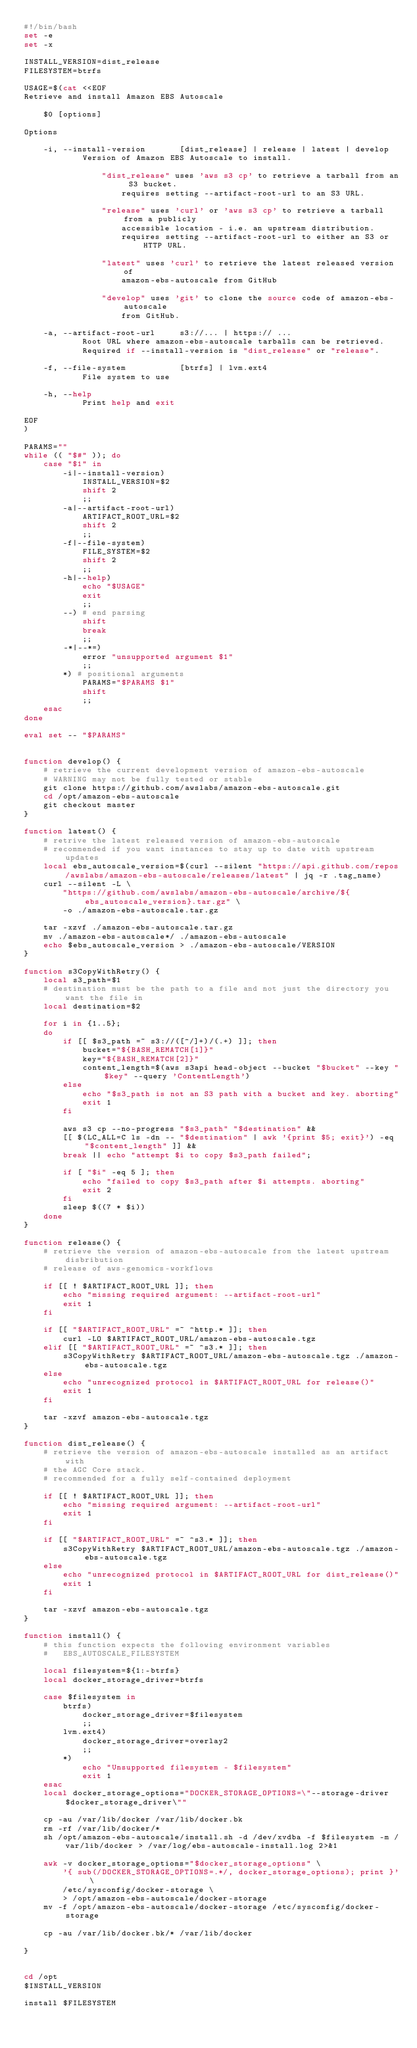<code> <loc_0><loc_0><loc_500><loc_500><_Bash_>#!/bin/bash
set -e
set -x

INSTALL_VERSION=dist_release
FILESYSTEM=btrfs

USAGE=$(cat <<EOF
Retrieve and install Amazon EBS Autoscale

    $0 [options]

Options

    -i, --install-version       [dist_release] | release | latest | develop
            Version of Amazon EBS Autoscale to install.
            
                "dist_release" uses 'aws s3 cp' to retrieve a tarball from an S3 bucket.
                    requires setting --artifact-root-url to an S3 URL.

                "release" uses 'curl' or 'aws s3 cp' to retrieve a tarball from a publicly 
                    accessible location - i.e. an upstream distribution.
                    requires setting --artifact-root-url to either an S3 or HTTP URL.
                
                "latest" uses 'curl' to retrieve the latest released version of 
                    amazon-ebs-autoscale from GitHub
                
                "develop" uses 'git' to clone the source code of amazon-ebs-autoscale
                    from GitHub.
    
    -a, --artifact-root-url     s3://... | https:// ...
            Root URL where amazon-ebs-autoscale tarballs can be retrieved.
            Required if --install-version is "dist_release" or "release".
    
    -f, --file-system           [btrfs] | lvm.ext4
            File system to use
    
    -h, --help
            Print help and exit

EOF
)

PARAMS=""
while (( "$#" )); do
    case "$1" in
        -i|--install-version)
            INSTALL_VERSION=$2
            shift 2
            ;;
        -a|--artifact-root-url)
            ARTIFACT_ROOT_URL=$2
            shift 2
            ;;
        -f|--file-system)
            FILE_SYSTEM=$2
            shift 2
            ;;
        -h|--help)
            echo "$USAGE"
            exit
            ;;
        --) # end parsing
            shift
            break
            ;;
        -*|--*=)
            error "unsupported argument $1"
            ;;
        *) # positional arguments
            PARAMS="$PARAMS $1"
            shift
            ;;
    esac
done

eval set -- "$PARAMS"


function develop() {
    # retrieve the current development version of amazon-ebs-autoscale
    # WARNING may not be fully tested or stable
    git clone https://github.com/awslabs/amazon-ebs-autoscale.git
    cd /opt/amazon-ebs-autoscale
    git checkout master
}

function latest() {
    # retrive the latest released version of amazon-ebs-autoscale
    # recommended if you want instances to stay up to date with upstream updates
    local ebs_autoscale_version=$(curl --silent "https://api.github.com/repos/awslabs/amazon-ebs-autoscale/releases/latest" | jq -r .tag_name)
    curl --silent -L \
        "https://github.com/awslabs/amazon-ebs-autoscale/archive/${ebs_autoscale_version}.tar.gz" \
        -o ./amazon-ebs-autoscale.tar.gz 

    tar -xzvf ./amazon-ebs-autoscale.tar.gz
    mv ./amazon-ebs-autoscale*/ ./amazon-ebs-autoscale
    echo $ebs_autoscale_version > ./amazon-ebs-autoscale/VERSION
}

function s3CopyWithRetry() {
    local s3_path=$1
    # destination must be the path to a file and not just the directory you want the file in
    local destination=$2

    for i in {1..5};
    do
        if [[ $s3_path =~ s3://([^/]+)/(.+) ]]; then
            bucket="${BASH_REMATCH[1]}"
            key="${BASH_REMATCH[2]}"
            content_length=$(aws s3api head-object --bucket "$bucket" --key "$key" --query 'ContentLength')
        else
            echo "$s3_path is not an S3 path with a bucket and key. aborting"
            exit 1
        fi
        
        aws s3 cp --no-progress "$s3_path" "$destination" &&
        [[ $(LC_ALL=C ls -dn -- "$destination" | awk '{print $5; exit}') -eq "$content_length" ]] &&
        break || echo "attempt $i to copy $s3_path failed";

        if [ "$i" -eq 5 ]; then
            echo "failed to copy $s3_path after $i attempts. aborting"
            exit 2
        fi
        sleep $((7 * $i))
    done
}

function release() {
    # retrieve the version of amazon-ebs-autoscale from the latest upstream disbribution 
    # release of aws-genomics-workflows

    if [[ ! $ARTIFACT_ROOT_URL ]]; then
        echo "missing required argument: --artifact-root-url"
        exit 1
    fi

    if [[ "$ARTIFACT_ROOT_URL" =~ ^http.* ]]; then
        curl -LO $ARTIFACT_ROOT_URL/amazon-ebs-autoscale.tgz
    elif [[ "$ARTIFACT_ROOT_URL" =~ ^s3.* ]]; then
        s3CopyWithRetry $ARTIFACT_ROOT_URL/amazon-ebs-autoscale.tgz ./amazon-ebs-autoscale.tgz
    else
        echo "unrecognized protocol in $ARTIFACT_ROOT_URL for release()"
        exit 1
    fi

    tar -xzvf amazon-ebs-autoscale.tgz
}

function dist_release() {
    # retrieve the version of amazon-ebs-autoscale installed as an artifact with
    # the AGC Core stack.
    # recommended for a fully self-contained deployment

    if [[ ! $ARTIFACT_ROOT_URL ]]; then
        echo "missing required argument: --artifact-root-url"
        exit 1
    fi

    if [[ "$ARTIFACT_ROOT_URL" =~ ^s3.* ]]; then
        s3CopyWithRetry $ARTIFACT_ROOT_URL/amazon-ebs-autoscale.tgz ./amazon-ebs-autoscale.tgz
    else
        echo "unrecognized protocol in $ARTIFACT_ROOT_URL for dist_release()"
        exit 1
    fi

    tar -xzvf amazon-ebs-autoscale.tgz
}

function install() {
    # this function expects the following environment variables
    #   EBS_AUTOSCALE_FILESYSTEM

    local filesystem=${1:-btrfs}
    local docker_storage_driver=btrfs

    case $filesystem in
        btrfs)
            docker_storage_driver=$filesystem
            ;;
        lvm.ext4)
            docker_storage_driver=overlay2
            ;;
        *)
            echo "Unsupported filesystem - $filesystem"
            exit 1
    esac
    local docker_storage_options="DOCKER_STORAGE_OPTIONS=\"--storage-driver $docker_storage_driver\""
    
    cp -au /var/lib/docker /var/lib/docker.bk
    rm -rf /var/lib/docker/*
    sh /opt/amazon-ebs-autoscale/install.sh -d /dev/xvdba -f $filesystem -m /var/lib/docker > /var/log/ebs-autoscale-install.log 2>&1

    awk -v docker_storage_options="$docker_storage_options" \
        '{ sub(/DOCKER_STORAGE_OPTIONS=.*/, docker_storage_options); print }' \
        /etc/sysconfig/docker-storage \
        > /opt/amazon-ebs-autoscale/docker-storage
    mv -f /opt/amazon-ebs-autoscale/docker-storage /etc/sysconfig/docker-storage

    cp -au /var/lib/docker.bk/* /var/lib/docker

}


cd /opt
$INSTALL_VERSION

install $FILESYSTEM</code> 